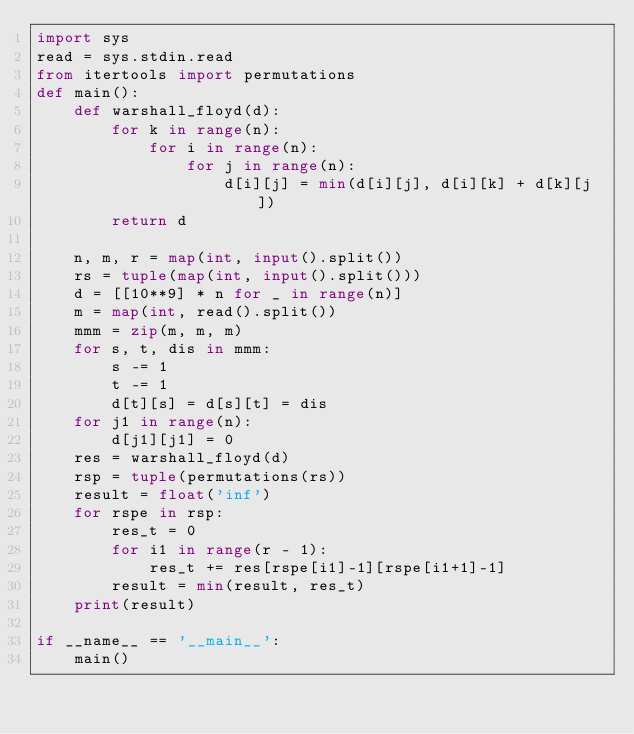<code> <loc_0><loc_0><loc_500><loc_500><_Python_>import sys
read = sys.stdin.read
from itertools import permutations
def main():
    def warshall_floyd(d):
        for k in range(n):
            for i in range(n):
                for j in range(n):
                    d[i][j] = min(d[i][j], d[i][k] + d[k][j])
        return d

    n, m, r = map(int, input().split())
    rs = tuple(map(int, input().split()))
    d = [[10**9] * n for _ in range(n)]
    m = map(int, read().split())
    mmm = zip(m, m, m)
    for s, t, dis in mmm:
        s -= 1
        t -= 1
        d[t][s] = d[s][t] = dis
    for j1 in range(n):
        d[j1][j1] = 0
    res = warshall_floyd(d)
    rsp = tuple(permutations(rs))
    result = float('inf')
    for rspe in rsp:
        res_t = 0
        for i1 in range(r - 1):
            res_t += res[rspe[i1]-1][rspe[i1+1]-1]
        result = min(result, res_t)
    print(result)

if __name__ == '__main__':
    main()
</code> 